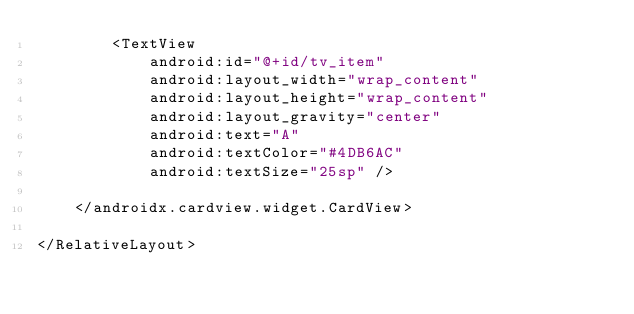<code> <loc_0><loc_0><loc_500><loc_500><_XML_>        <TextView
            android:id="@+id/tv_item"
            android:layout_width="wrap_content"
            android:layout_height="wrap_content"
            android:layout_gravity="center"
            android:text="A"
            android:textColor="#4DB6AC"
            android:textSize="25sp" />

    </androidx.cardview.widget.CardView>

</RelativeLayout></code> 